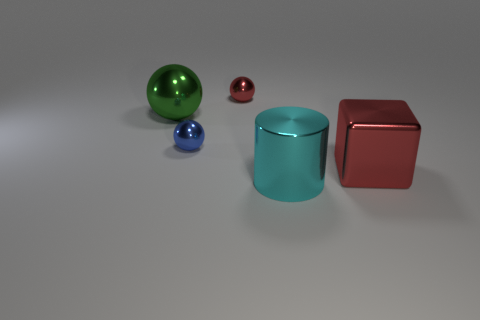Subtract all large green metal spheres. How many spheres are left? 2 Add 4 big shiny balls. How many objects exist? 9 Subtract all cubes. How many objects are left? 4 Subtract all red balls. How many balls are left? 2 Subtract all red cylinders. How many purple blocks are left? 0 Subtract all large balls. Subtract all small cyan cubes. How many objects are left? 4 Add 4 cyan shiny cylinders. How many cyan shiny cylinders are left? 5 Add 1 large yellow metal balls. How many large yellow metal balls exist? 1 Subtract 0 brown balls. How many objects are left? 5 Subtract 1 cylinders. How many cylinders are left? 0 